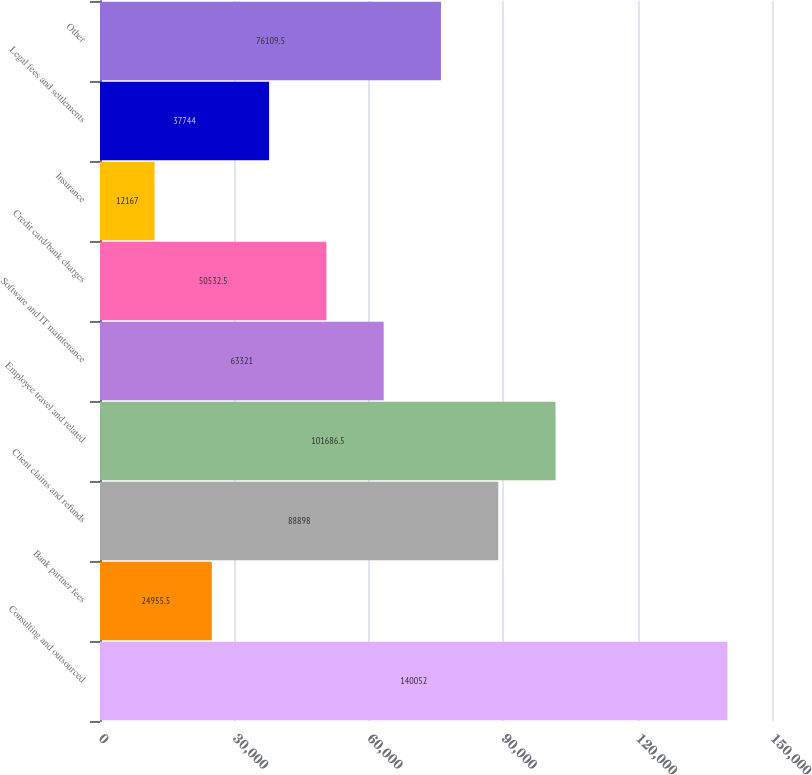Convert chart to OTSL. <chart><loc_0><loc_0><loc_500><loc_500><bar_chart><fcel>Consulting and outsourced<fcel>Bank partner fees<fcel>Client claims and refunds<fcel>Employee travel and related<fcel>Software and IT maintenance<fcel>Credit card/bank charges<fcel>Insurance<fcel>Legal fees and settlements<fcel>Other<nl><fcel>140052<fcel>24955.5<fcel>88898<fcel>101686<fcel>63321<fcel>50532.5<fcel>12167<fcel>37744<fcel>76109.5<nl></chart> 